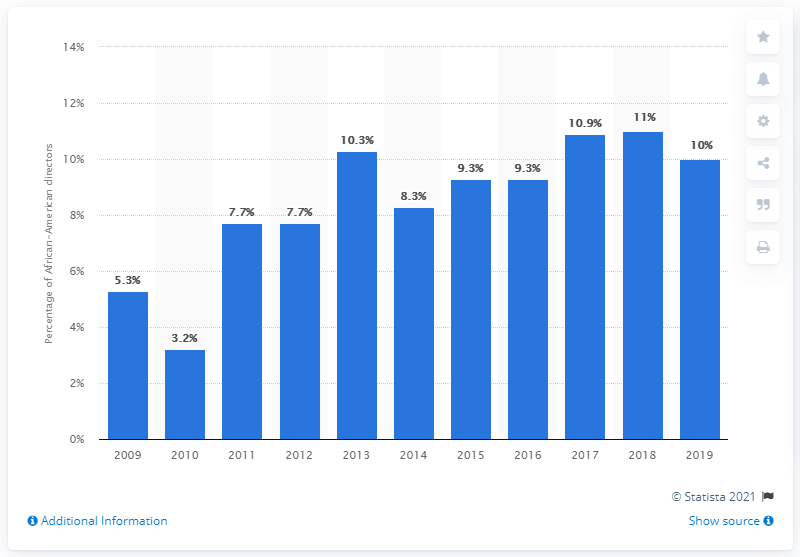List a handful of essential elements in this visual. I'm sorry, but I'm not sure what you are asking. Could you please provide more context or clarify your question? The percentage of African-American board members decreased significantly from 2009 to 2019. 